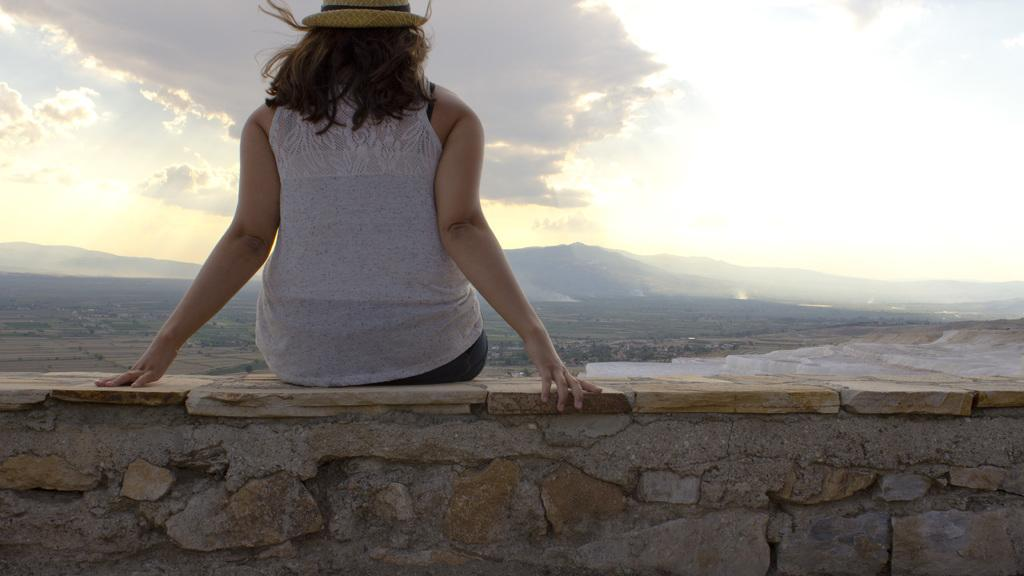Who is the main subject in the image? There is a lady in the image. What is the lady wearing on her head? The lady is wearing a cap. Where is the lady sitting in the image? The lady is sitting on a wall. What is visible at the top of the image? The sky is visible at the top of the image. What type of texture can be seen on the desk in the image? There is no desk present in the image; the lady is sitting on a wall. 